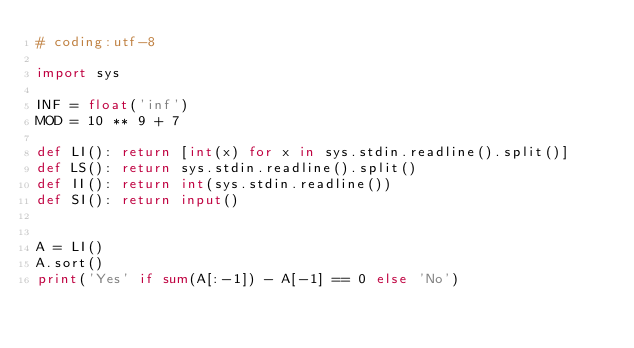<code> <loc_0><loc_0><loc_500><loc_500><_Python_># coding:utf-8

import sys

INF = float('inf')
MOD = 10 ** 9 + 7

def LI(): return [int(x) for x in sys.stdin.readline().split()]
def LS(): return sys.stdin.readline().split()
def II(): return int(sys.stdin.readline())
def SI(): return input()


A = LI()
A.sort()
print('Yes' if sum(A[:-1]) - A[-1] == 0 else 'No')
</code> 